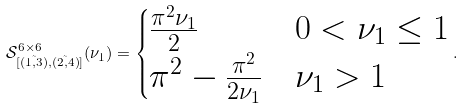Convert formula to latex. <formula><loc_0><loc_0><loc_500><loc_500>\mathcal { S } _ { [ \tilde { ( 1 , 3 ) } , \tilde { ( 2 , 4 ) } ] } ^ { 6 \times 6 } ( \nu _ { 1 } ) = \begin{cases} \frac { \pi ^ { 2 } \nu _ { 1 } } { 2 } & 0 < \nu _ { 1 } \leq 1 \\ \pi ^ { 2 } - \frac { \pi ^ { 2 } } { 2 \nu _ { 1 } } & \nu _ { 1 } > 1 \end{cases} .</formula> 